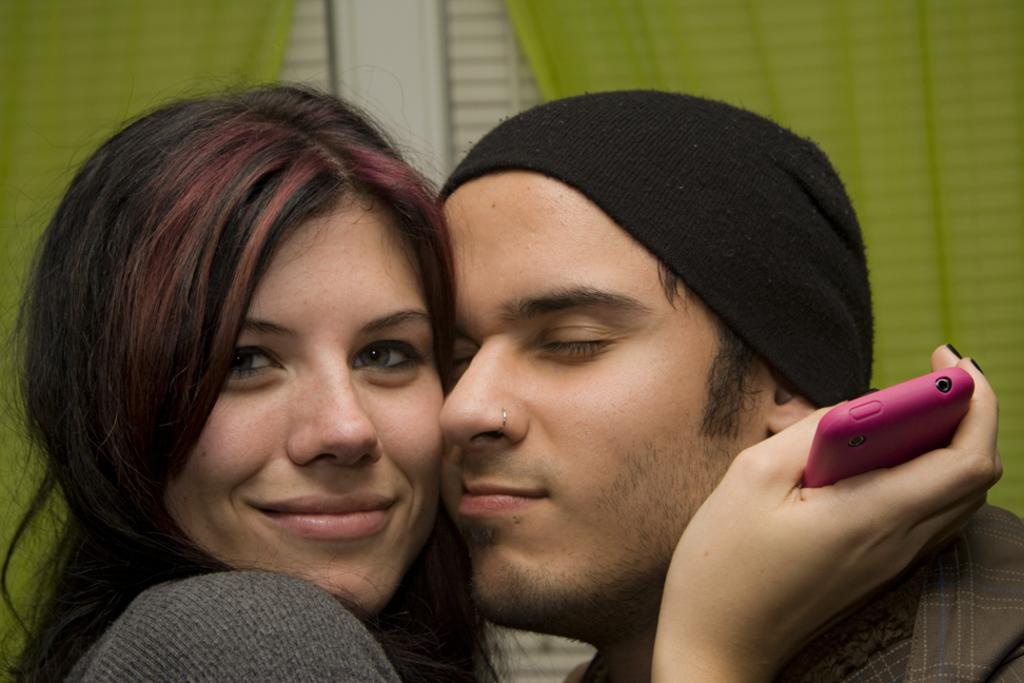Who are the people in the image? There is a girl and a boy in the image. What is the girl holding in the image? The girl is holding a mobile phone. What color is the cloth visible on the back side? The cloth visible on the back side is green. What type of butter is being used to navigate the map in the image? There is no butter or map present in the image. 